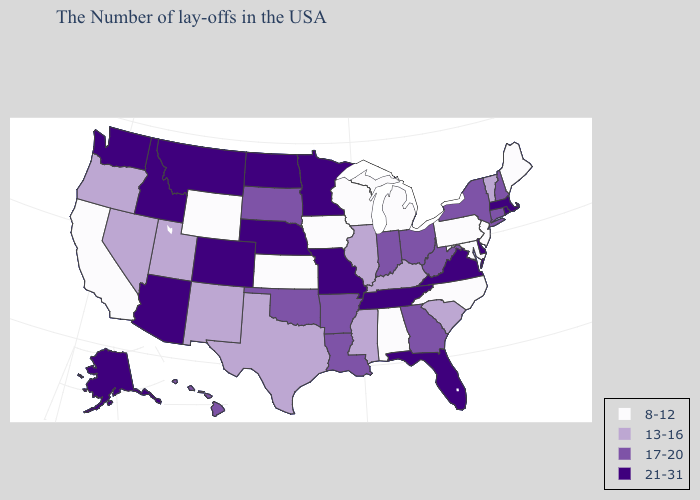Name the states that have a value in the range 8-12?
Keep it brief. Maine, New Jersey, Maryland, Pennsylvania, North Carolina, Michigan, Alabama, Wisconsin, Iowa, Kansas, Wyoming, California. Name the states that have a value in the range 21-31?
Keep it brief. Massachusetts, Rhode Island, Delaware, Virginia, Florida, Tennessee, Missouri, Minnesota, Nebraska, North Dakota, Colorado, Montana, Arizona, Idaho, Washington, Alaska. Which states have the lowest value in the South?
Quick response, please. Maryland, North Carolina, Alabama. What is the lowest value in states that border Oregon?
Give a very brief answer. 8-12. Does Montana have the lowest value in the USA?
Short answer required. No. Name the states that have a value in the range 13-16?
Be succinct. Vermont, South Carolina, Kentucky, Illinois, Mississippi, Texas, New Mexico, Utah, Nevada, Oregon. Among the states that border Texas , which have the lowest value?
Write a very short answer. New Mexico. What is the lowest value in the USA?
Keep it brief. 8-12. Does Tennessee have the highest value in the USA?
Answer briefly. Yes. Among the states that border Virginia , which have the lowest value?
Concise answer only. Maryland, North Carolina. What is the value of North Carolina?
Write a very short answer. 8-12. Which states have the lowest value in the USA?
Answer briefly. Maine, New Jersey, Maryland, Pennsylvania, North Carolina, Michigan, Alabama, Wisconsin, Iowa, Kansas, Wyoming, California. Does South Dakota have the lowest value in the USA?
Be succinct. No. What is the highest value in states that border West Virginia?
Give a very brief answer. 21-31. Which states have the lowest value in the MidWest?
Quick response, please. Michigan, Wisconsin, Iowa, Kansas. 